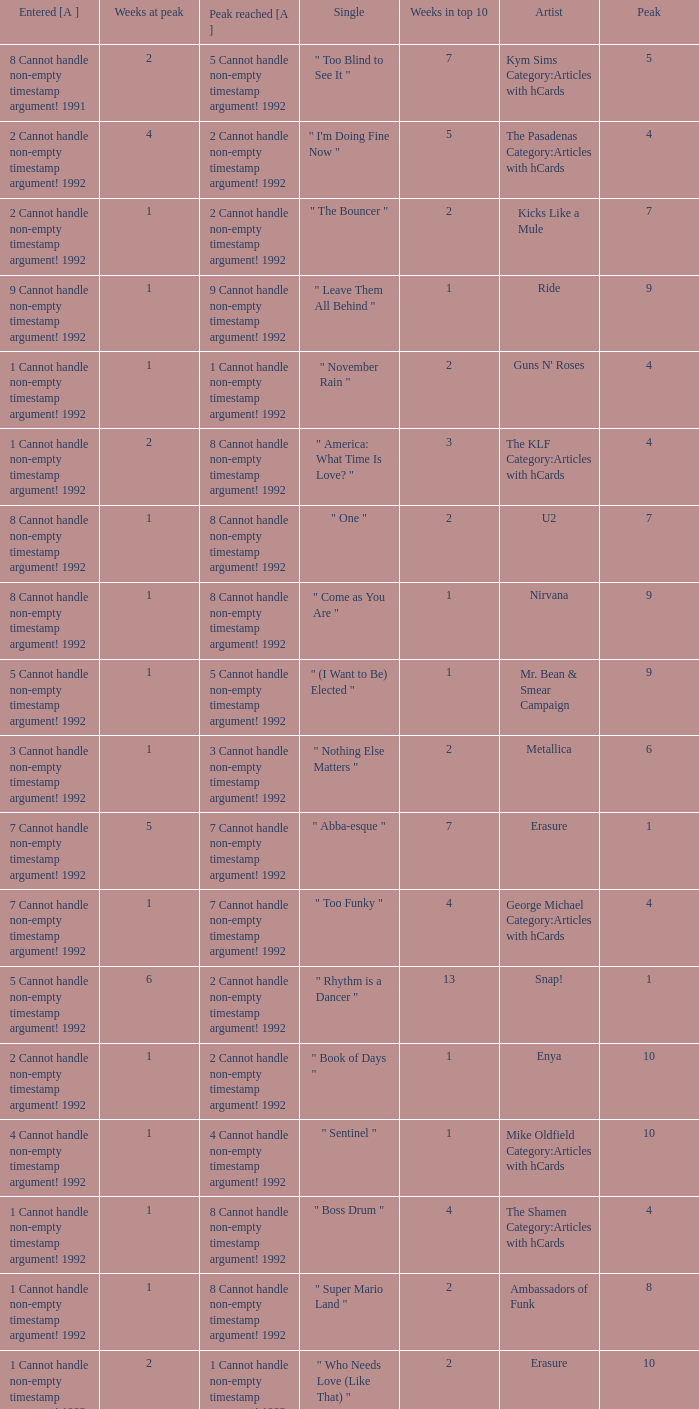If the peak is 9, how many weeks was it in the top 10? 1.0. 